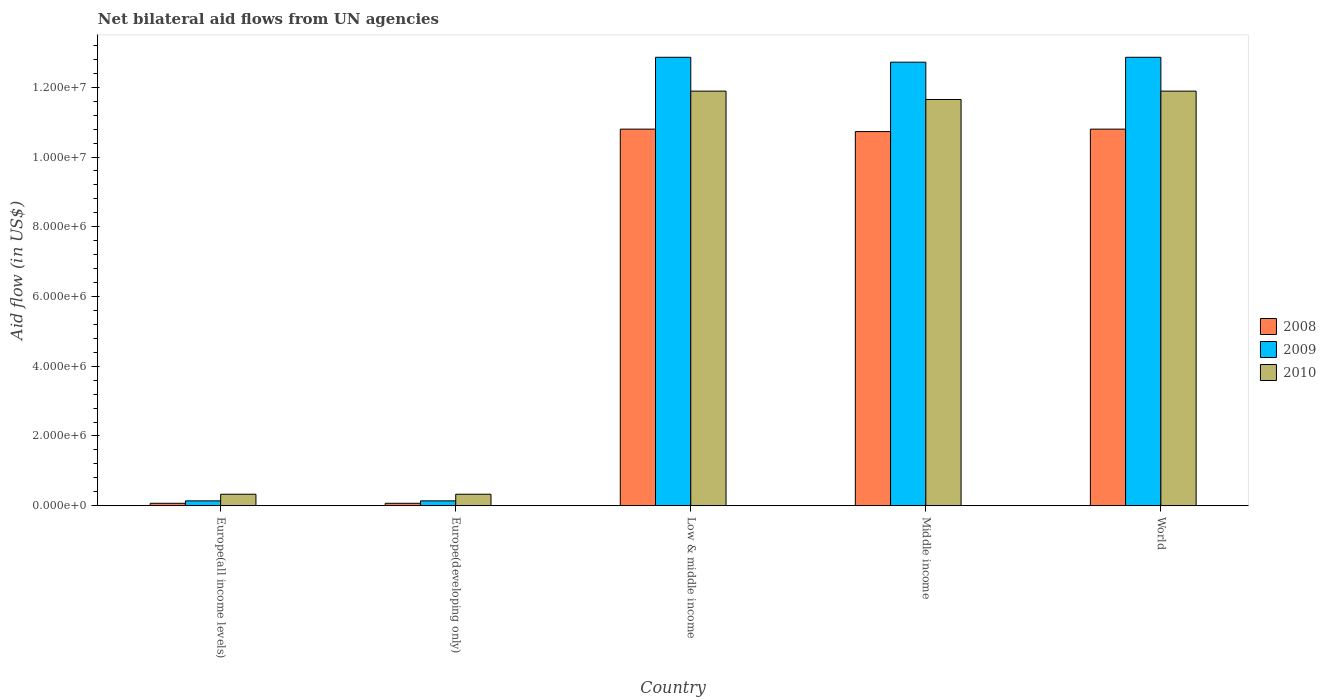How many different coloured bars are there?
Ensure brevity in your answer.  3. Are the number of bars on each tick of the X-axis equal?
Your answer should be very brief. Yes. How many bars are there on the 4th tick from the left?
Your response must be concise. 3. What is the net bilateral aid flow in 2010 in Low & middle income?
Provide a succinct answer. 1.19e+07. Across all countries, what is the maximum net bilateral aid flow in 2010?
Offer a very short reply. 1.19e+07. In which country was the net bilateral aid flow in 2010 minimum?
Offer a terse response. Europe(all income levels). What is the total net bilateral aid flow in 2008 in the graph?
Offer a terse response. 3.25e+07. What is the difference between the net bilateral aid flow in 2009 in Middle income and the net bilateral aid flow in 2008 in Europe(developing only)?
Keep it short and to the point. 1.26e+07. What is the average net bilateral aid flow in 2008 per country?
Provide a succinct answer. 6.49e+06. What is the difference between the net bilateral aid flow of/in 2009 and net bilateral aid flow of/in 2010 in Europe(all income levels)?
Keep it short and to the point. -1.90e+05. What is the ratio of the net bilateral aid flow in 2008 in Europe(all income levels) to that in Middle income?
Your answer should be very brief. 0.01. Is the net bilateral aid flow in 2009 in Middle income less than that in World?
Offer a very short reply. Yes. What is the difference between the highest and the lowest net bilateral aid flow in 2008?
Make the answer very short. 1.07e+07. In how many countries, is the net bilateral aid flow in 2010 greater than the average net bilateral aid flow in 2010 taken over all countries?
Provide a succinct answer. 3. Is the sum of the net bilateral aid flow in 2009 in Europe(all income levels) and Low & middle income greater than the maximum net bilateral aid flow in 2008 across all countries?
Provide a short and direct response. Yes. What does the 1st bar from the left in Low & middle income represents?
Provide a succinct answer. 2008. What does the 3rd bar from the right in Middle income represents?
Your answer should be compact. 2008. How many bars are there?
Keep it short and to the point. 15. How many countries are there in the graph?
Provide a short and direct response. 5. What is the difference between two consecutive major ticks on the Y-axis?
Your answer should be compact. 2.00e+06. Does the graph contain any zero values?
Offer a terse response. No. Does the graph contain grids?
Provide a succinct answer. No. What is the title of the graph?
Your answer should be compact. Net bilateral aid flows from UN agencies. What is the label or title of the Y-axis?
Provide a succinct answer. Aid flow (in US$). What is the Aid flow (in US$) of 2008 in Europe(all income levels)?
Make the answer very short. 7.00e+04. What is the Aid flow (in US$) in 2009 in Europe(developing only)?
Offer a very short reply. 1.40e+05. What is the Aid flow (in US$) in 2010 in Europe(developing only)?
Give a very brief answer. 3.30e+05. What is the Aid flow (in US$) in 2008 in Low & middle income?
Provide a short and direct response. 1.08e+07. What is the Aid flow (in US$) in 2009 in Low & middle income?
Make the answer very short. 1.29e+07. What is the Aid flow (in US$) of 2010 in Low & middle income?
Make the answer very short. 1.19e+07. What is the Aid flow (in US$) of 2008 in Middle income?
Give a very brief answer. 1.07e+07. What is the Aid flow (in US$) in 2009 in Middle income?
Keep it short and to the point. 1.27e+07. What is the Aid flow (in US$) of 2010 in Middle income?
Offer a very short reply. 1.16e+07. What is the Aid flow (in US$) in 2008 in World?
Your answer should be very brief. 1.08e+07. What is the Aid flow (in US$) of 2009 in World?
Your answer should be very brief. 1.29e+07. What is the Aid flow (in US$) of 2010 in World?
Provide a short and direct response. 1.19e+07. Across all countries, what is the maximum Aid flow (in US$) of 2008?
Give a very brief answer. 1.08e+07. Across all countries, what is the maximum Aid flow (in US$) of 2009?
Provide a succinct answer. 1.29e+07. Across all countries, what is the maximum Aid flow (in US$) of 2010?
Keep it short and to the point. 1.19e+07. Across all countries, what is the minimum Aid flow (in US$) in 2008?
Give a very brief answer. 7.00e+04. Across all countries, what is the minimum Aid flow (in US$) of 2010?
Your answer should be compact. 3.30e+05. What is the total Aid flow (in US$) of 2008 in the graph?
Your answer should be compact. 3.25e+07. What is the total Aid flow (in US$) in 2009 in the graph?
Provide a succinct answer. 3.87e+07. What is the total Aid flow (in US$) in 2010 in the graph?
Provide a succinct answer. 3.61e+07. What is the difference between the Aid flow (in US$) in 2010 in Europe(all income levels) and that in Europe(developing only)?
Make the answer very short. 0. What is the difference between the Aid flow (in US$) in 2008 in Europe(all income levels) and that in Low & middle income?
Provide a short and direct response. -1.07e+07. What is the difference between the Aid flow (in US$) of 2009 in Europe(all income levels) and that in Low & middle income?
Provide a succinct answer. -1.27e+07. What is the difference between the Aid flow (in US$) of 2010 in Europe(all income levels) and that in Low & middle income?
Make the answer very short. -1.16e+07. What is the difference between the Aid flow (in US$) in 2008 in Europe(all income levels) and that in Middle income?
Give a very brief answer. -1.07e+07. What is the difference between the Aid flow (in US$) of 2009 in Europe(all income levels) and that in Middle income?
Your answer should be very brief. -1.26e+07. What is the difference between the Aid flow (in US$) of 2010 in Europe(all income levels) and that in Middle income?
Provide a succinct answer. -1.13e+07. What is the difference between the Aid flow (in US$) of 2008 in Europe(all income levels) and that in World?
Offer a very short reply. -1.07e+07. What is the difference between the Aid flow (in US$) in 2009 in Europe(all income levels) and that in World?
Ensure brevity in your answer.  -1.27e+07. What is the difference between the Aid flow (in US$) of 2010 in Europe(all income levels) and that in World?
Make the answer very short. -1.16e+07. What is the difference between the Aid flow (in US$) of 2008 in Europe(developing only) and that in Low & middle income?
Your answer should be compact. -1.07e+07. What is the difference between the Aid flow (in US$) of 2009 in Europe(developing only) and that in Low & middle income?
Provide a short and direct response. -1.27e+07. What is the difference between the Aid flow (in US$) of 2010 in Europe(developing only) and that in Low & middle income?
Give a very brief answer. -1.16e+07. What is the difference between the Aid flow (in US$) in 2008 in Europe(developing only) and that in Middle income?
Offer a terse response. -1.07e+07. What is the difference between the Aid flow (in US$) of 2009 in Europe(developing only) and that in Middle income?
Your answer should be compact. -1.26e+07. What is the difference between the Aid flow (in US$) in 2010 in Europe(developing only) and that in Middle income?
Your response must be concise. -1.13e+07. What is the difference between the Aid flow (in US$) of 2008 in Europe(developing only) and that in World?
Your answer should be compact. -1.07e+07. What is the difference between the Aid flow (in US$) of 2009 in Europe(developing only) and that in World?
Provide a succinct answer. -1.27e+07. What is the difference between the Aid flow (in US$) of 2010 in Europe(developing only) and that in World?
Ensure brevity in your answer.  -1.16e+07. What is the difference between the Aid flow (in US$) of 2009 in Low & middle income and that in Middle income?
Keep it short and to the point. 1.40e+05. What is the difference between the Aid flow (in US$) of 2008 in Low & middle income and that in World?
Offer a terse response. 0. What is the difference between the Aid flow (in US$) in 2009 in Low & middle income and that in World?
Provide a short and direct response. 0. What is the difference between the Aid flow (in US$) in 2008 in Middle income and that in World?
Make the answer very short. -7.00e+04. What is the difference between the Aid flow (in US$) of 2010 in Middle income and that in World?
Keep it short and to the point. -2.40e+05. What is the difference between the Aid flow (in US$) of 2008 in Europe(all income levels) and the Aid flow (in US$) of 2009 in Europe(developing only)?
Offer a terse response. -7.00e+04. What is the difference between the Aid flow (in US$) of 2008 in Europe(all income levels) and the Aid flow (in US$) of 2009 in Low & middle income?
Offer a terse response. -1.28e+07. What is the difference between the Aid flow (in US$) of 2008 in Europe(all income levels) and the Aid flow (in US$) of 2010 in Low & middle income?
Offer a very short reply. -1.18e+07. What is the difference between the Aid flow (in US$) of 2009 in Europe(all income levels) and the Aid flow (in US$) of 2010 in Low & middle income?
Your answer should be compact. -1.18e+07. What is the difference between the Aid flow (in US$) in 2008 in Europe(all income levels) and the Aid flow (in US$) in 2009 in Middle income?
Your response must be concise. -1.26e+07. What is the difference between the Aid flow (in US$) of 2008 in Europe(all income levels) and the Aid flow (in US$) of 2010 in Middle income?
Give a very brief answer. -1.16e+07. What is the difference between the Aid flow (in US$) of 2009 in Europe(all income levels) and the Aid flow (in US$) of 2010 in Middle income?
Provide a succinct answer. -1.15e+07. What is the difference between the Aid flow (in US$) of 2008 in Europe(all income levels) and the Aid flow (in US$) of 2009 in World?
Provide a succinct answer. -1.28e+07. What is the difference between the Aid flow (in US$) of 2008 in Europe(all income levels) and the Aid flow (in US$) of 2010 in World?
Provide a short and direct response. -1.18e+07. What is the difference between the Aid flow (in US$) in 2009 in Europe(all income levels) and the Aid flow (in US$) in 2010 in World?
Your answer should be compact. -1.18e+07. What is the difference between the Aid flow (in US$) of 2008 in Europe(developing only) and the Aid flow (in US$) of 2009 in Low & middle income?
Provide a short and direct response. -1.28e+07. What is the difference between the Aid flow (in US$) of 2008 in Europe(developing only) and the Aid flow (in US$) of 2010 in Low & middle income?
Give a very brief answer. -1.18e+07. What is the difference between the Aid flow (in US$) of 2009 in Europe(developing only) and the Aid flow (in US$) of 2010 in Low & middle income?
Your answer should be compact. -1.18e+07. What is the difference between the Aid flow (in US$) in 2008 in Europe(developing only) and the Aid flow (in US$) in 2009 in Middle income?
Offer a very short reply. -1.26e+07. What is the difference between the Aid flow (in US$) of 2008 in Europe(developing only) and the Aid flow (in US$) of 2010 in Middle income?
Provide a short and direct response. -1.16e+07. What is the difference between the Aid flow (in US$) in 2009 in Europe(developing only) and the Aid flow (in US$) in 2010 in Middle income?
Your response must be concise. -1.15e+07. What is the difference between the Aid flow (in US$) in 2008 in Europe(developing only) and the Aid flow (in US$) in 2009 in World?
Give a very brief answer. -1.28e+07. What is the difference between the Aid flow (in US$) of 2008 in Europe(developing only) and the Aid flow (in US$) of 2010 in World?
Provide a succinct answer. -1.18e+07. What is the difference between the Aid flow (in US$) of 2009 in Europe(developing only) and the Aid flow (in US$) of 2010 in World?
Provide a succinct answer. -1.18e+07. What is the difference between the Aid flow (in US$) in 2008 in Low & middle income and the Aid flow (in US$) in 2009 in Middle income?
Give a very brief answer. -1.92e+06. What is the difference between the Aid flow (in US$) of 2008 in Low & middle income and the Aid flow (in US$) of 2010 in Middle income?
Ensure brevity in your answer.  -8.50e+05. What is the difference between the Aid flow (in US$) of 2009 in Low & middle income and the Aid flow (in US$) of 2010 in Middle income?
Provide a short and direct response. 1.21e+06. What is the difference between the Aid flow (in US$) in 2008 in Low & middle income and the Aid flow (in US$) in 2009 in World?
Give a very brief answer. -2.06e+06. What is the difference between the Aid flow (in US$) of 2008 in Low & middle income and the Aid flow (in US$) of 2010 in World?
Your response must be concise. -1.09e+06. What is the difference between the Aid flow (in US$) in 2009 in Low & middle income and the Aid flow (in US$) in 2010 in World?
Offer a very short reply. 9.70e+05. What is the difference between the Aid flow (in US$) of 2008 in Middle income and the Aid flow (in US$) of 2009 in World?
Ensure brevity in your answer.  -2.13e+06. What is the difference between the Aid flow (in US$) of 2008 in Middle income and the Aid flow (in US$) of 2010 in World?
Keep it short and to the point. -1.16e+06. What is the difference between the Aid flow (in US$) of 2009 in Middle income and the Aid flow (in US$) of 2010 in World?
Your answer should be compact. 8.30e+05. What is the average Aid flow (in US$) in 2008 per country?
Your answer should be very brief. 6.49e+06. What is the average Aid flow (in US$) in 2009 per country?
Give a very brief answer. 7.74e+06. What is the average Aid flow (in US$) of 2010 per country?
Offer a terse response. 7.22e+06. What is the difference between the Aid flow (in US$) of 2008 and Aid flow (in US$) of 2010 in Europe(developing only)?
Give a very brief answer. -2.60e+05. What is the difference between the Aid flow (in US$) in 2009 and Aid flow (in US$) in 2010 in Europe(developing only)?
Offer a very short reply. -1.90e+05. What is the difference between the Aid flow (in US$) in 2008 and Aid flow (in US$) in 2009 in Low & middle income?
Your answer should be compact. -2.06e+06. What is the difference between the Aid flow (in US$) of 2008 and Aid flow (in US$) of 2010 in Low & middle income?
Your response must be concise. -1.09e+06. What is the difference between the Aid flow (in US$) in 2009 and Aid flow (in US$) in 2010 in Low & middle income?
Your answer should be very brief. 9.70e+05. What is the difference between the Aid flow (in US$) in 2008 and Aid flow (in US$) in 2009 in Middle income?
Give a very brief answer. -1.99e+06. What is the difference between the Aid flow (in US$) in 2008 and Aid flow (in US$) in 2010 in Middle income?
Make the answer very short. -9.20e+05. What is the difference between the Aid flow (in US$) of 2009 and Aid flow (in US$) of 2010 in Middle income?
Offer a terse response. 1.07e+06. What is the difference between the Aid flow (in US$) of 2008 and Aid flow (in US$) of 2009 in World?
Ensure brevity in your answer.  -2.06e+06. What is the difference between the Aid flow (in US$) in 2008 and Aid flow (in US$) in 2010 in World?
Your response must be concise. -1.09e+06. What is the difference between the Aid flow (in US$) in 2009 and Aid flow (in US$) in 2010 in World?
Keep it short and to the point. 9.70e+05. What is the ratio of the Aid flow (in US$) in 2009 in Europe(all income levels) to that in Europe(developing only)?
Make the answer very short. 1. What is the ratio of the Aid flow (in US$) in 2008 in Europe(all income levels) to that in Low & middle income?
Keep it short and to the point. 0.01. What is the ratio of the Aid flow (in US$) in 2009 in Europe(all income levels) to that in Low & middle income?
Provide a short and direct response. 0.01. What is the ratio of the Aid flow (in US$) of 2010 in Europe(all income levels) to that in Low & middle income?
Offer a terse response. 0.03. What is the ratio of the Aid flow (in US$) in 2008 in Europe(all income levels) to that in Middle income?
Ensure brevity in your answer.  0.01. What is the ratio of the Aid flow (in US$) of 2009 in Europe(all income levels) to that in Middle income?
Your answer should be compact. 0.01. What is the ratio of the Aid flow (in US$) of 2010 in Europe(all income levels) to that in Middle income?
Provide a succinct answer. 0.03. What is the ratio of the Aid flow (in US$) of 2008 in Europe(all income levels) to that in World?
Your answer should be very brief. 0.01. What is the ratio of the Aid flow (in US$) of 2009 in Europe(all income levels) to that in World?
Make the answer very short. 0.01. What is the ratio of the Aid flow (in US$) in 2010 in Europe(all income levels) to that in World?
Give a very brief answer. 0.03. What is the ratio of the Aid flow (in US$) of 2008 in Europe(developing only) to that in Low & middle income?
Your answer should be very brief. 0.01. What is the ratio of the Aid flow (in US$) in 2009 in Europe(developing only) to that in Low & middle income?
Your answer should be compact. 0.01. What is the ratio of the Aid flow (in US$) of 2010 in Europe(developing only) to that in Low & middle income?
Offer a terse response. 0.03. What is the ratio of the Aid flow (in US$) of 2008 in Europe(developing only) to that in Middle income?
Ensure brevity in your answer.  0.01. What is the ratio of the Aid flow (in US$) of 2009 in Europe(developing only) to that in Middle income?
Provide a short and direct response. 0.01. What is the ratio of the Aid flow (in US$) in 2010 in Europe(developing only) to that in Middle income?
Your answer should be compact. 0.03. What is the ratio of the Aid flow (in US$) in 2008 in Europe(developing only) to that in World?
Your answer should be compact. 0.01. What is the ratio of the Aid flow (in US$) of 2009 in Europe(developing only) to that in World?
Make the answer very short. 0.01. What is the ratio of the Aid flow (in US$) in 2010 in Europe(developing only) to that in World?
Your answer should be very brief. 0.03. What is the ratio of the Aid flow (in US$) in 2008 in Low & middle income to that in Middle income?
Your answer should be very brief. 1.01. What is the ratio of the Aid flow (in US$) in 2010 in Low & middle income to that in Middle income?
Your answer should be very brief. 1.02. What is the ratio of the Aid flow (in US$) of 2008 in Low & middle income to that in World?
Your response must be concise. 1. What is the ratio of the Aid flow (in US$) in 2009 in Low & middle income to that in World?
Provide a short and direct response. 1. What is the ratio of the Aid flow (in US$) of 2010 in Low & middle income to that in World?
Give a very brief answer. 1. What is the ratio of the Aid flow (in US$) of 2010 in Middle income to that in World?
Give a very brief answer. 0.98. What is the difference between the highest and the lowest Aid flow (in US$) of 2008?
Offer a very short reply. 1.07e+07. What is the difference between the highest and the lowest Aid flow (in US$) of 2009?
Your answer should be compact. 1.27e+07. What is the difference between the highest and the lowest Aid flow (in US$) in 2010?
Offer a terse response. 1.16e+07. 